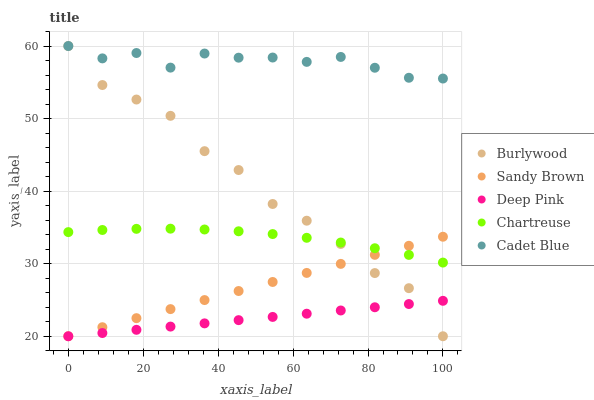Does Deep Pink have the minimum area under the curve?
Answer yes or no. Yes. Does Cadet Blue have the maximum area under the curve?
Answer yes or no. Yes. Does Chartreuse have the minimum area under the curve?
Answer yes or no. No. Does Chartreuse have the maximum area under the curve?
Answer yes or no. No. Is Deep Pink the smoothest?
Answer yes or no. Yes. Is Burlywood the roughest?
Answer yes or no. Yes. Is Chartreuse the smoothest?
Answer yes or no. No. Is Chartreuse the roughest?
Answer yes or no. No. Does Burlywood have the lowest value?
Answer yes or no. Yes. Does Chartreuse have the lowest value?
Answer yes or no. No. Does Cadet Blue have the highest value?
Answer yes or no. Yes. Does Chartreuse have the highest value?
Answer yes or no. No. Is Chartreuse less than Cadet Blue?
Answer yes or no. Yes. Is Cadet Blue greater than Deep Pink?
Answer yes or no. Yes. Does Burlywood intersect Cadet Blue?
Answer yes or no. Yes. Is Burlywood less than Cadet Blue?
Answer yes or no. No. Is Burlywood greater than Cadet Blue?
Answer yes or no. No. Does Chartreuse intersect Cadet Blue?
Answer yes or no. No. 